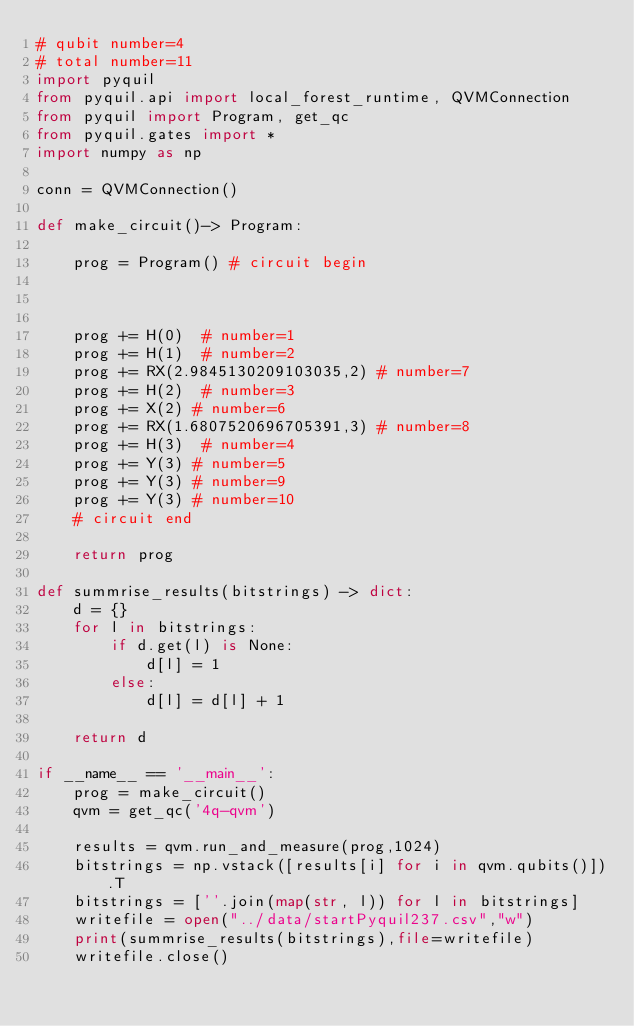Convert code to text. <code><loc_0><loc_0><loc_500><loc_500><_Python_># qubit number=4
# total number=11
import pyquil
from pyquil.api import local_forest_runtime, QVMConnection
from pyquil import Program, get_qc
from pyquil.gates import *
import numpy as np

conn = QVMConnection()

def make_circuit()-> Program:

    prog = Program() # circuit begin



    prog += H(0)  # number=1
    prog += H(1)  # number=2
    prog += RX(2.9845130209103035,2) # number=7
    prog += H(2)  # number=3
    prog += X(2) # number=6
    prog += RX(1.6807520696705391,3) # number=8
    prog += H(3)  # number=4
    prog += Y(3) # number=5
    prog += Y(3) # number=9
    prog += Y(3) # number=10
    # circuit end

    return prog

def summrise_results(bitstrings) -> dict:
    d = {}
    for l in bitstrings:
        if d.get(l) is None:
            d[l] = 1
        else:
            d[l] = d[l] + 1

    return d

if __name__ == '__main__':
    prog = make_circuit()
    qvm = get_qc('4q-qvm')

    results = qvm.run_and_measure(prog,1024)
    bitstrings = np.vstack([results[i] for i in qvm.qubits()]).T
    bitstrings = [''.join(map(str, l)) for l in bitstrings]
    writefile = open("../data/startPyquil237.csv","w")
    print(summrise_results(bitstrings),file=writefile)
    writefile.close()

</code> 